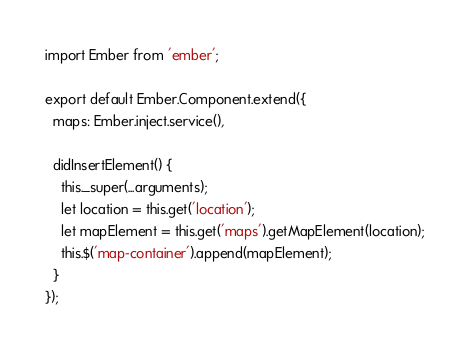Convert code to text. <code><loc_0><loc_0><loc_500><loc_500><_JavaScript_>import Ember from 'ember';

export default Ember.Component.extend({
  maps: Ember.inject.service(),

  didInsertElement() {
    this._super(...arguments);
    let location = this.get('location');
    let mapElement = this.get('maps').getMapElement(location);
    this.$('map-container').append(mapElement);
  }
});
</code> 